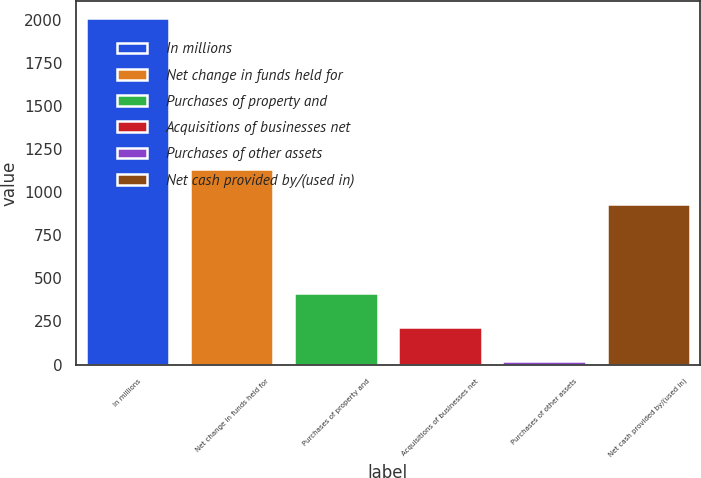<chart> <loc_0><loc_0><loc_500><loc_500><bar_chart><fcel>In millions<fcel>Net change in funds held for<fcel>Purchases of property and<fcel>Acquisitions of businesses net<fcel>Purchases of other assets<fcel>Net cash provided by/(used in)<nl><fcel>2008<fcel>1132.04<fcel>417.28<fcel>218.44<fcel>19.6<fcel>933.2<nl></chart> 